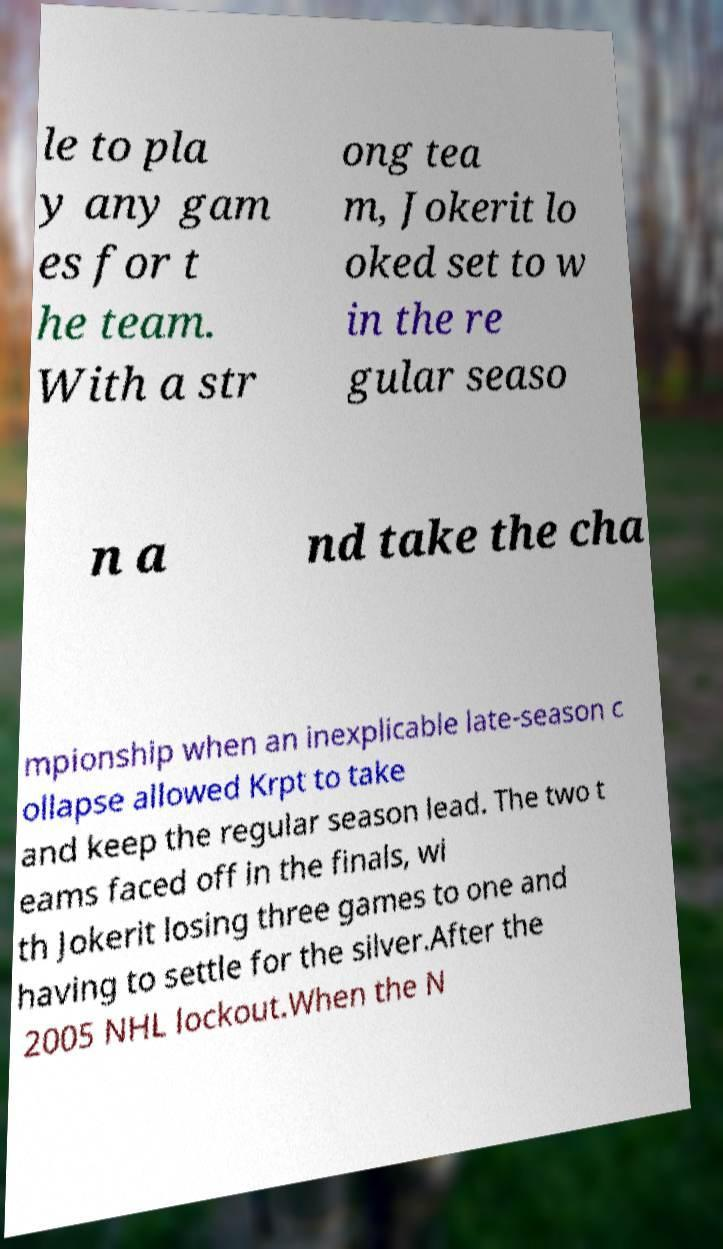For documentation purposes, I need the text within this image transcribed. Could you provide that? le to pla y any gam es for t he team. With a str ong tea m, Jokerit lo oked set to w in the re gular seaso n a nd take the cha mpionship when an inexplicable late-season c ollapse allowed Krpt to take and keep the regular season lead. The two t eams faced off in the finals, wi th Jokerit losing three games to one and having to settle for the silver.After the 2005 NHL lockout.When the N 